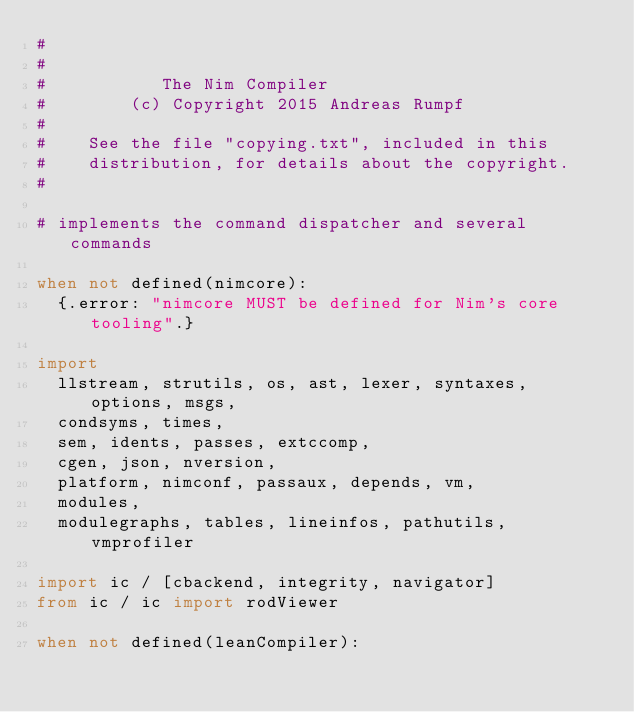<code> <loc_0><loc_0><loc_500><loc_500><_Nim_>#
#
#           The Nim Compiler
#        (c) Copyright 2015 Andreas Rumpf
#
#    See the file "copying.txt", included in this
#    distribution, for details about the copyright.
#

# implements the command dispatcher and several commands

when not defined(nimcore):
  {.error: "nimcore MUST be defined for Nim's core tooling".}

import
  llstream, strutils, os, ast, lexer, syntaxes, options, msgs,
  condsyms, times,
  sem, idents, passes, extccomp,
  cgen, json, nversion,
  platform, nimconf, passaux, depends, vm,
  modules,
  modulegraphs, tables, lineinfos, pathutils, vmprofiler

import ic / [cbackend, integrity, navigator]
from ic / ic import rodViewer

when not defined(leanCompiler):</code> 